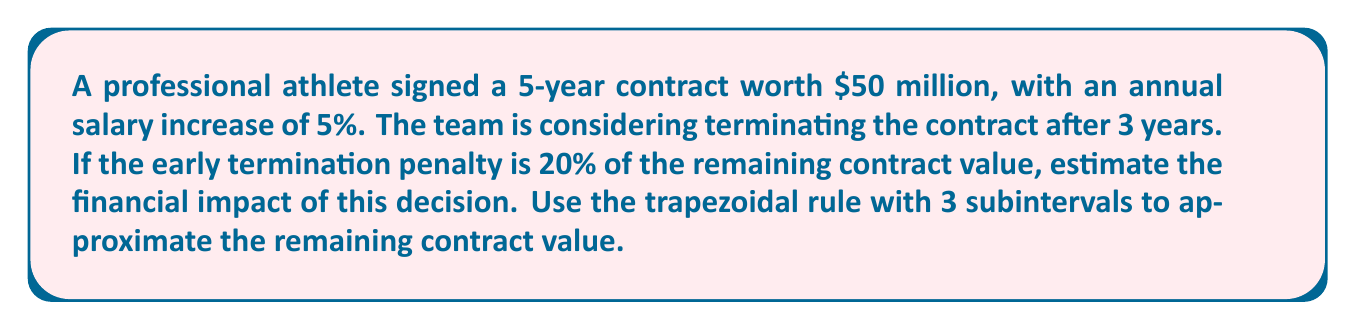Could you help me with this problem? 1. First, we need to determine the salary for each year:
   Year 1: $50M ÷ 5 = $10M
   Year 2: $10M × 1.05 = $10.5M
   Year 3: $10.5M × 1.05 = $11.025M
   Year 4: $11.025M × 1.05 = $11.57625M
   Year 5: $11.57625M × 1.05 = $12.1550625M

2. We need to estimate the remaining contract value for years 4 and 5 using the trapezoidal rule with 3 subintervals.

3. The trapezoidal rule formula is:
   $$\int_{a}^{b} f(x) dx \approx \frac{b-a}{2n} [f(x_0) + 2f(x_1) + 2f(x_2) + ... + 2f(x_{n-1}) + f(x_n)]$$

4. In our case:
   $a = 3$ (start of year 4)
   $b = 5$ (end of year 5)
   $n = 3$ (number of subintervals)

5. Calculate the step size:
   $$h = \frac{b-a}{n} = \frac{5-3}{3} = \frac{2}{3}$$

6. Calculate the x-values:
   $x_0 = 3$
   $x_1 = 3 + \frac{2}{3} = 3.6667$
   $x_2 = 3 + \frac{4}{3} = 4.3333$
   $x_3 = 5$

7. Calculate the corresponding y-values (salaries):
   $f(x_0) = 11.57625$
   $f(x_1) = 11.57625 \times 1.05^{0.6667} = 11.9559$
   $f(x_2) = 11.57625 \times 1.05^{1.3333} = 12.3482$
   $f(x_3) = 12.1550625$

8. Apply the trapezoidal rule:
   $$\text{Remaining Value} \approx \frac{2}{2(3)} [11.57625 + 2(11.9559) + 2(12.3482) + 12.1550625]$$
   $$= \frac{1}{3} [11.57625 + 23.9118 + 24.6964 + 12.1550625]$$
   $$= \frac{72.3395125}{3} = 24.1131708$$

9. Calculate the early termination penalty:
   $$\text{Penalty} = 20\% \times 24.1131708 = 4.8226342$$

10. The financial impact is the sum of the remaining value and the penalty:
    $$\text{Financial Impact} = 24.1131708 + 4.8226342 = 28.935805$$
Answer: $28.94 million 